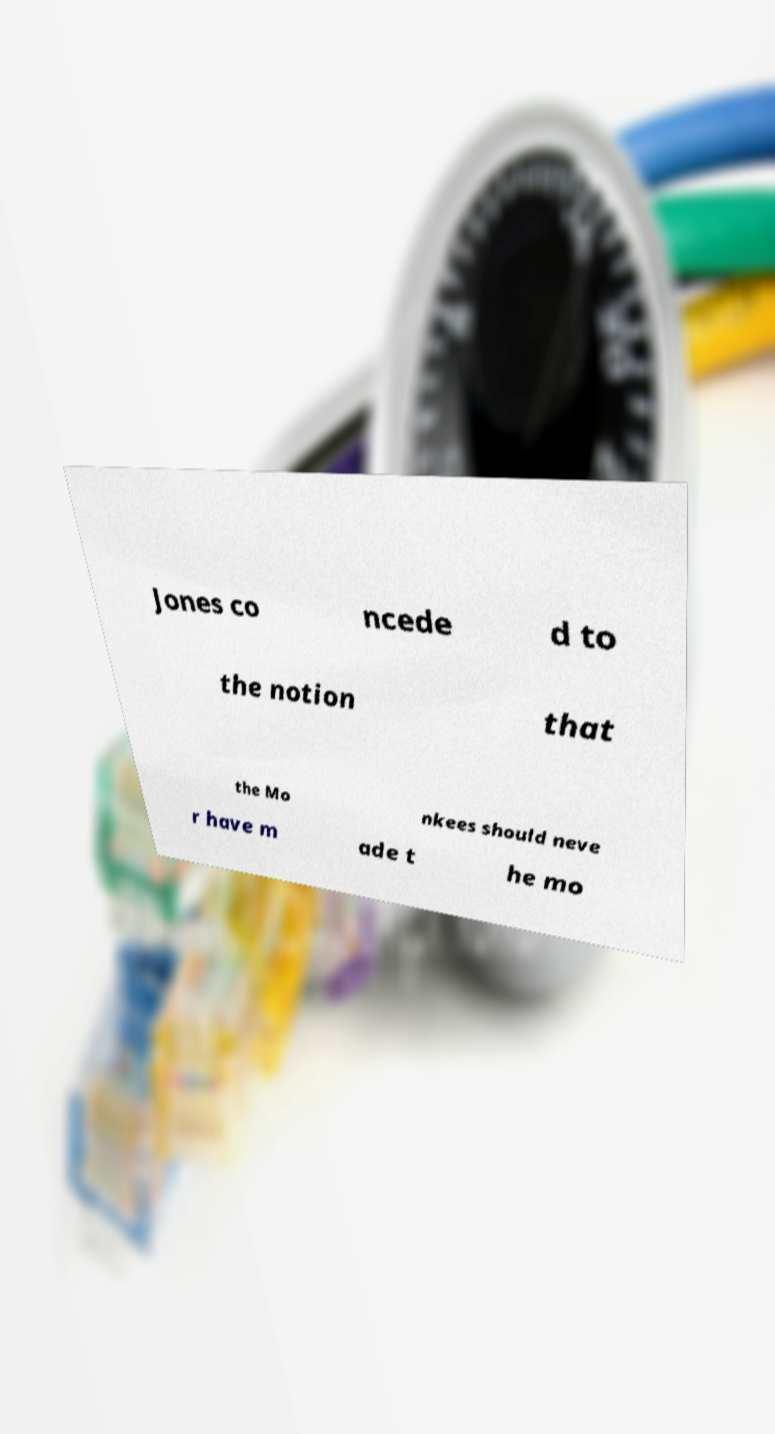Please identify and transcribe the text found in this image. Jones co ncede d to the notion that the Mo nkees should neve r have m ade t he mo 